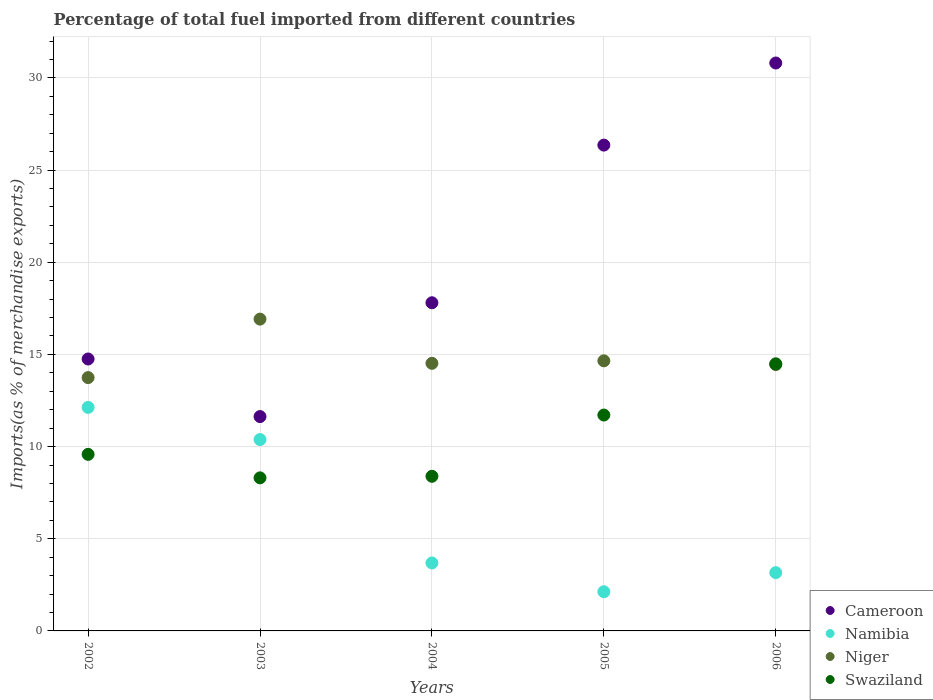How many different coloured dotlines are there?
Your response must be concise. 4. What is the percentage of imports to different countries in Swaziland in 2006?
Offer a terse response. 14.49. Across all years, what is the maximum percentage of imports to different countries in Niger?
Make the answer very short. 16.91. Across all years, what is the minimum percentage of imports to different countries in Swaziland?
Provide a short and direct response. 8.3. What is the total percentage of imports to different countries in Niger in the graph?
Your answer should be very brief. 74.28. What is the difference between the percentage of imports to different countries in Swaziland in 2002 and that in 2006?
Offer a very short reply. -4.91. What is the difference between the percentage of imports to different countries in Namibia in 2006 and the percentage of imports to different countries in Cameroon in 2004?
Make the answer very short. -14.64. What is the average percentage of imports to different countries in Cameroon per year?
Your response must be concise. 20.27. In the year 2004, what is the difference between the percentage of imports to different countries in Niger and percentage of imports to different countries in Cameroon?
Offer a very short reply. -3.29. In how many years, is the percentage of imports to different countries in Namibia greater than 19 %?
Make the answer very short. 0. What is the ratio of the percentage of imports to different countries in Namibia in 2004 to that in 2006?
Provide a short and direct response. 1.17. Is the percentage of imports to different countries in Cameroon in 2002 less than that in 2003?
Your answer should be very brief. No. What is the difference between the highest and the second highest percentage of imports to different countries in Cameroon?
Offer a very short reply. 4.45. What is the difference between the highest and the lowest percentage of imports to different countries in Cameroon?
Give a very brief answer. 19.18. Is the sum of the percentage of imports to different countries in Swaziland in 2005 and 2006 greater than the maximum percentage of imports to different countries in Namibia across all years?
Offer a terse response. Yes. Is it the case that in every year, the sum of the percentage of imports to different countries in Niger and percentage of imports to different countries in Cameroon  is greater than the sum of percentage of imports to different countries in Swaziland and percentage of imports to different countries in Namibia?
Make the answer very short. No. Is it the case that in every year, the sum of the percentage of imports to different countries in Namibia and percentage of imports to different countries in Swaziland  is greater than the percentage of imports to different countries in Niger?
Offer a very short reply. No. Does the percentage of imports to different countries in Niger monotonically increase over the years?
Make the answer very short. No. Is the percentage of imports to different countries in Niger strictly greater than the percentage of imports to different countries in Swaziland over the years?
Offer a very short reply. No. Is the percentage of imports to different countries in Niger strictly less than the percentage of imports to different countries in Swaziland over the years?
Offer a very short reply. No. How many years are there in the graph?
Offer a very short reply. 5. Are the values on the major ticks of Y-axis written in scientific E-notation?
Provide a short and direct response. No. How many legend labels are there?
Make the answer very short. 4. How are the legend labels stacked?
Offer a terse response. Vertical. What is the title of the graph?
Your response must be concise. Percentage of total fuel imported from different countries. What is the label or title of the X-axis?
Your response must be concise. Years. What is the label or title of the Y-axis?
Provide a succinct answer. Imports(as % of merchandise exports). What is the Imports(as % of merchandise exports) in Cameroon in 2002?
Your answer should be compact. 14.75. What is the Imports(as % of merchandise exports) in Namibia in 2002?
Your answer should be very brief. 12.13. What is the Imports(as % of merchandise exports) of Niger in 2002?
Provide a succinct answer. 13.74. What is the Imports(as % of merchandise exports) of Swaziland in 2002?
Provide a short and direct response. 9.58. What is the Imports(as % of merchandise exports) in Cameroon in 2003?
Ensure brevity in your answer.  11.63. What is the Imports(as % of merchandise exports) in Namibia in 2003?
Give a very brief answer. 10.38. What is the Imports(as % of merchandise exports) of Niger in 2003?
Your answer should be compact. 16.91. What is the Imports(as % of merchandise exports) of Swaziland in 2003?
Offer a terse response. 8.3. What is the Imports(as % of merchandise exports) of Cameroon in 2004?
Offer a very short reply. 17.8. What is the Imports(as % of merchandise exports) of Namibia in 2004?
Make the answer very short. 3.69. What is the Imports(as % of merchandise exports) in Niger in 2004?
Make the answer very short. 14.52. What is the Imports(as % of merchandise exports) of Swaziland in 2004?
Your response must be concise. 8.39. What is the Imports(as % of merchandise exports) in Cameroon in 2005?
Offer a terse response. 26.35. What is the Imports(as % of merchandise exports) of Namibia in 2005?
Provide a short and direct response. 2.13. What is the Imports(as % of merchandise exports) of Niger in 2005?
Ensure brevity in your answer.  14.65. What is the Imports(as % of merchandise exports) of Swaziland in 2005?
Keep it short and to the point. 11.71. What is the Imports(as % of merchandise exports) of Cameroon in 2006?
Make the answer very short. 30.81. What is the Imports(as % of merchandise exports) in Namibia in 2006?
Make the answer very short. 3.16. What is the Imports(as % of merchandise exports) in Niger in 2006?
Provide a short and direct response. 14.45. What is the Imports(as % of merchandise exports) in Swaziland in 2006?
Offer a terse response. 14.49. Across all years, what is the maximum Imports(as % of merchandise exports) in Cameroon?
Your answer should be compact. 30.81. Across all years, what is the maximum Imports(as % of merchandise exports) in Namibia?
Provide a short and direct response. 12.13. Across all years, what is the maximum Imports(as % of merchandise exports) of Niger?
Your answer should be compact. 16.91. Across all years, what is the maximum Imports(as % of merchandise exports) in Swaziland?
Make the answer very short. 14.49. Across all years, what is the minimum Imports(as % of merchandise exports) of Cameroon?
Ensure brevity in your answer.  11.63. Across all years, what is the minimum Imports(as % of merchandise exports) in Namibia?
Provide a succinct answer. 2.13. Across all years, what is the minimum Imports(as % of merchandise exports) in Niger?
Provide a succinct answer. 13.74. Across all years, what is the minimum Imports(as % of merchandise exports) in Swaziland?
Offer a terse response. 8.3. What is the total Imports(as % of merchandise exports) in Cameroon in the graph?
Provide a succinct answer. 101.35. What is the total Imports(as % of merchandise exports) in Namibia in the graph?
Give a very brief answer. 31.48. What is the total Imports(as % of merchandise exports) of Niger in the graph?
Keep it short and to the point. 74.28. What is the total Imports(as % of merchandise exports) of Swaziland in the graph?
Offer a terse response. 52.47. What is the difference between the Imports(as % of merchandise exports) in Cameroon in 2002 and that in 2003?
Offer a very short reply. 3.12. What is the difference between the Imports(as % of merchandise exports) of Namibia in 2002 and that in 2003?
Keep it short and to the point. 1.74. What is the difference between the Imports(as % of merchandise exports) in Niger in 2002 and that in 2003?
Offer a very short reply. -3.17. What is the difference between the Imports(as % of merchandise exports) in Swaziland in 2002 and that in 2003?
Make the answer very short. 1.28. What is the difference between the Imports(as % of merchandise exports) of Cameroon in 2002 and that in 2004?
Offer a very short reply. -3.05. What is the difference between the Imports(as % of merchandise exports) of Namibia in 2002 and that in 2004?
Keep it short and to the point. 8.44. What is the difference between the Imports(as % of merchandise exports) of Niger in 2002 and that in 2004?
Provide a succinct answer. -0.78. What is the difference between the Imports(as % of merchandise exports) in Swaziland in 2002 and that in 2004?
Make the answer very short. 1.19. What is the difference between the Imports(as % of merchandise exports) of Cameroon in 2002 and that in 2005?
Provide a succinct answer. -11.6. What is the difference between the Imports(as % of merchandise exports) in Namibia in 2002 and that in 2005?
Make the answer very short. 10. What is the difference between the Imports(as % of merchandise exports) of Niger in 2002 and that in 2005?
Your response must be concise. -0.91. What is the difference between the Imports(as % of merchandise exports) of Swaziland in 2002 and that in 2005?
Your response must be concise. -2.13. What is the difference between the Imports(as % of merchandise exports) of Cameroon in 2002 and that in 2006?
Make the answer very short. -16.06. What is the difference between the Imports(as % of merchandise exports) in Namibia in 2002 and that in 2006?
Provide a short and direct response. 8.96. What is the difference between the Imports(as % of merchandise exports) of Niger in 2002 and that in 2006?
Give a very brief answer. -0.71. What is the difference between the Imports(as % of merchandise exports) in Swaziland in 2002 and that in 2006?
Your answer should be compact. -4.91. What is the difference between the Imports(as % of merchandise exports) in Cameroon in 2003 and that in 2004?
Your answer should be compact. -6.17. What is the difference between the Imports(as % of merchandise exports) in Namibia in 2003 and that in 2004?
Your answer should be compact. 6.69. What is the difference between the Imports(as % of merchandise exports) in Niger in 2003 and that in 2004?
Your answer should be compact. 2.4. What is the difference between the Imports(as % of merchandise exports) of Swaziland in 2003 and that in 2004?
Provide a short and direct response. -0.09. What is the difference between the Imports(as % of merchandise exports) of Cameroon in 2003 and that in 2005?
Your answer should be compact. -14.73. What is the difference between the Imports(as % of merchandise exports) in Namibia in 2003 and that in 2005?
Your answer should be compact. 8.26. What is the difference between the Imports(as % of merchandise exports) in Niger in 2003 and that in 2005?
Offer a very short reply. 2.26. What is the difference between the Imports(as % of merchandise exports) in Swaziland in 2003 and that in 2005?
Make the answer very short. -3.41. What is the difference between the Imports(as % of merchandise exports) in Cameroon in 2003 and that in 2006?
Ensure brevity in your answer.  -19.18. What is the difference between the Imports(as % of merchandise exports) in Namibia in 2003 and that in 2006?
Your answer should be very brief. 7.22. What is the difference between the Imports(as % of merchandise exports) in Niger in 2003 and that in 2006?
Give a very brief answer. 2.47. What is the difference between the Imports(as % of merchandise exports) in Swaziland in 2003 and that in 2006?
Make the answer very short. -6.19. What is the difference between the Imports(as % of merchandise exports) in Cameroon in 2004 and that in 2005?
Offer a terse response. -8.55. What is the difference between the Imports(as % of merchandise exports) in Namibia in 2004 and that in 2005?
Give a very brief answer. 1.56. What is the difference between the Imports(as % of merchandise exports) of Niger in 2004 and that in 2005?
Give a very brief answer. -0.14. What is the difference between the Imports(as % of merchandise exports) in Swaziland in 2004 and that in 2005?
Make the answer very short. -3.32. What is the difference between the Imports(as % of merchandise exports) in Cameroon in 2004 and that in 2006?
Ensure brevity in your answer.  -13.01. What is the difference between the Imports(as % of merchandise exports) of Namibia in 2004 and that in 2006?
Provide a short and direct response. 0.53. What is the difference between the Imports(as % of merchandise exports) of Niger in 2004 and that in 2006?
Your answer should be very brief. 0.07. What is the difference between the Imports(as % of merchandise exports) of Swaziland in 2004 and that in 2006?
Offer a terse response. -6.1. What is the difference between the Imports(as % of merchandise exports) in Cameroon in 2005 and that in 2006?
Offer a terse response. -4.45. What is the difference between the Imports(as % of merchandise exports) in Namibia in 2005 and that in 2006?
Your answer should be compact. -1.04. What is the difference between the Imports(as % of merchandise exports) of Niger in 2005 and that in 2006?
Offer a terse response. 0.2. What is the difference between the Imports(as % of merchandise exports) in Swaziland in 2005 and that in 2006?
Give a very brief answer. -2.78. What is the difference between the Imports(as % of merchandise exports) in Cameroon in 2002 and the Imports(as % of merchandise exports) in Namibia in 2003?
Provide a short and direct response. 4.37. What is the difference between the Imports(as % of merchandise exports) in Cameroon in 2002 and the Imports(as % of merchandise exports) in Niger in 2003?
Provide a succinct answer. -2.16. What is the difference between the Imports(as % of merchandise exports) of Cameroon in 2002 and the Imports(as % of merchandise exports) of Swaziland in 2003?
Provide a short and direct response. 6.45. What is the difference between the Imports(as % of merchandise exports) of Namibia in 2002 and the Imports(as % of merchandise exports) of Niger in 2003?
Provide a succinct answer. -4.79. What is the difference between the Imports(as % of merchandise exports) in Namibia in 2002 and the Imports(as % of merchandise exports) in Swaziland in 2003?
Ensure brevity in your answer.  3.82. What is the difference between the Imports(as % of merchandise exports) of Niger in 2002 and the Imports(as % of merchandise exports) of Swaziland in 2003?
Make the answer very short. 5.44. What is the difference between the Imports(as % of merchandise exports) in Cameroon in 2002 and the Imports(as % of merchandise exports) in Namibia in 2004?
Your answer should be compact. 11.06. What is the difference between the Imports(as % of merchandise exports) in Cameroon in 2002 and the Imports(as % of merchandise exports) in Niger in 2004?
Ensure brevity in your answer.  0.23. What is the difference between the Imports(as % of merchandise exports) in Cameroon in 2002 and the Imports(as % of merchandise exports) in Swaziland in 2004?
Provide a succinct answer. 6.36. What is the difference between the Imports(as % of merchandise exports) in Namibia in 2002 and the Imports(as % of merchandise exports) in Niger in 2004?
Your answer should be very brief. -2.39. What is the difference between the Imports(as % of merchandise exports) in Namibia in 2002 and the Imports(as % of merchandise exports) in Swaziland in 2004?
Provide a succinct answer. 3.74. What is the difference between the Imports(as % of merchandise exports) of Niger in 2002 and the Imports(as % of merchandise exports) of Swaziland in 2004?
Your answer should be very brief. 5.35. What is the difference between the Imports(as % of merchandise exports) in Cameroon in 2002 and the Imports(as % of merchandise exports) in Namibia in 2005?
Provide a short and direct response. 12.63. What is the difference between the Imports(as % of merchandise exports) in Cameroon in 2002 and the Imports(as % of merchandise exports) in Niger in 2005?
Make the answer very short. 0.1. What is the difference between the Imports(as % of merchandise exports) of Cameroon in 2002 and the Imports(as % of merchandise exports) of Swaziland in 2005?
Make the answer very short. 3.04. What is the difference between the Imports(as % of merchandise exports) of Namibia in 2002 and the Imports(as % of merchandise exports) of Niger in 2005?
Offer a very short reply. -2.53. What is the difference between the Imports(as % of merchandise exports) of Namibia in 2002 and the Imports(as % of merchandise exports) of Swaziland in 2005?
Provide a short and direct response. 0.41. What is the difference between the Imports(as % of merchandise exports) of Niger in 2002 and the Imports(as % of merchandise exports) of Swaziland in 2005?
Offer a terse response. 2.03. What is the difference between the Imports(as % of merchandise exports) of Cameroon in 2002 and the Imports(as % of merchandise exports) of Namibia in 2006?
Provide a succinct answer. 11.59. What is the difference between the Imports(as % of merchandise exports) in Cameroon in 2002 and the Imports(as % of merchandise exports) in Niger in 2006?
Provide a short and direct response. 0.3. What is the difference between the Imports(as % of merchandise exports) of Cameroon in 2002 and the Imports(as % of merchandise exports) of Swaziland in 2006?
Ensure brevity in your answer.  0.26. What is the difference between the Imports(as % of merchandise exports) in Namibia in 2002 and the Imports(as % of merchandise exports) in Niger in 2006?
Give a very brief answer. -2.32. What is the difference between the Imports(as % of merchandise exports) in Namibia in 2002 and the Imports(as % of merchandise exports) in Swaziland in 2006?
Make the answer very short. -2.36. What is the difference between the Imports(as % of merchandise exports) of Niger in 2002 and the Imports(as % of merchandise exports) of Swaziland in 2006?
Provide a succinct answer. -0.75. What is the difference between the Imports(as % of merchandise exports) of Cameroon in 2003 and the Imports(as % of merchandise exports) of Namibia in 2004?
Make the answer very short. 7.94. What is the difference between the Imports(as % of merchandise exports) of Cameroon in 2003 and the Imports(as % of merchandise exports) of Niger in 2004?
Provide a succinct answer. -2.89. What is the difference between the Imports(as % of merchandise exports) of Cameroon in 2003 and the Imports(as % of merchandise exports) of Swaziland in 2004?
Provide a succinct answer. 3.24. What is the difference between the Imports(as % of merchandise exports) in Namibia in 2003 and the Imports(as % of merchandise exports) in Niger in 2004?
Ensure brevity in your answer.  -4.14. What is the difference between the Imports(as % of merchandise exports) in Namibia in 2003 and the Imports(as % of merchandise exports) in Swaziland in 2004?
Your response must be concise. 1.99. What is the difference between the Imports(as % of merchandise exports) in Niger in 2003 and the Imports(as % of merchandise exports) in Swaziland in 2004?
Give a very brief answer. 8.53. What is the difference between the Imports(as % of merchandise exports) of Cameroon in 2003 and the Imports(as % of merchandise exports) of Namibia in 2005?
Make the answer very short. 9.5. What is the difference between the Imports(as % of merchandise exports) in Cameroon in 2003 and the Imports(as % of merchandise exports) in Niger in 2005?
Your response must be concise. -3.02. What is the difference between the Imports(as % of merchandise exports) of Cameroon in 2003 and the Imports(as % of merchandise exports) of Swaziland in 2005?
Your answer should be compact. -0.08. What is the difference between the Imports(as % of merchandise exports) of Namibia in 2003 and the Imports(as % of merchandise exports) of Niger in 2005?
Provide a short and direct response. -4.27. What is the difference between the Imports(as % of merchandise exports) in Namibia in 2003 and the Imports(as % of merchandise exports) in Swaziland in 2005?
Give a very brief answer. -1.33. What is the difference between the Imports(as % of merchandise exports) of Niger in 2003 and the Imports(as % of merchandise exports) of Swaziland in 2005?
Your response must be concise. 5.2. What is the difference between the Imports(as % of merchandise exports) in Cameroon in 2003 and the Imports(as % of merchandise exports) in Namibia in 2006?
Your response must be concise. 8.47. What is the difference between the Imports(as % of merchandise exports) of Cameroon in 2003 and the Imports(as % of merchandise exports) of Niger in 2006?
Ensure brevity in your answer.  -2.82. What is the difference between the Imports(as % of merchandise exports) in Cameroon in 2003 and the Imports(as % of merchandise exports) in Swaziland in 2006?
Your answer should be compact. -2.86. What is the difference between the Imports(as % of merchandise exports) in Namibia in 2003 and the Imports(as % of merchandise exports) in Niger in 2006?
Your answer should be compact. -4.07. What is the difference between the Imports(as % of merchandise exports) of Namibia in 2003 and the Imports(as % of merchandise exports) of Swaziland in 2006?
Make the answer very short. -4.11. What is the difference between the Imports(as % of merchandise exports) of Niger in 2003 and the Imports(as % of merchandise exports) of Swaziland in 2006?
Offer a very short reply. 2.42. What is the difference between the Imports(as % of merchandise exports) in Cameroon in 2004 and the Imports(as % of merchandise exports) in Namibia in 2005?
Your response must be concise. 15.68. What is the difference between the Imports(as % of merchandise exports) in Cameroon in 2004 and the Imports(as % of merchandise exports) in Niger in 2005?
Offer a terse response. 3.15. What is the difference between the Imports(as % of merchandise exports) in Cameroon in 2004 and the Imports(as % of merchandise exports) in Swaziland in 2005?
Offer a very short reply. 6.09. What is the difference between the Imports(as % of merchandise exports) in Namibia in 2004 and the Imports(as % of merchandise exports) in Niger in 2005?
Give a very brief answer. -10.97. What is the difference between the Imports(as % of merchandise exports) in Namibia in 2004 and the Imports(as % of merchandise exports) in Swaziland in 2005?
Offer a very short reply. -8.02. What is the difference between the Imports(as % of merchandise exports) of Niger in 2004 and the Imports(as % of merchandise exports) of Swaziland in 2005?
Make the answer very short. 2.81. What is the difference between the Imports(as % of merchandise exports) of Cameroon in 2004 and the Imports(as % of merchandise exports) of Namibia in 2006?
Provide a succinct answer. 14.64. What is the difference between the Imports(as % of merchandise exports) of Cameroon in 2004 and the Imports(as % of merchandise exports) of Niger in 2006?
Offer a very short reply. 3.35. What is the difference between the Imports(as % of merchandise exports) in Cameroon in 2004 and the Imports(as % of merchandise exports) in Swaziland in 2006?
Your answer should be compact. 3.31. What is the difference between the Imports(as % of merchandise exports) of Namibia in 2004 and the Imports(as % of merchandise exports) of Niger in 2006?
Keep it short and to the point. -10.76. What is the difference between the Imports(as % of merchandise exports) in Namibia in 2004 and the Imports(as % of merchandise exports) in Swaziland in 2006?
Keep it short and to the point. -10.8. What is the difference between the Imports(as % of merchandise exports) in Niger in 2004 and the Imports(as % of merchandise exports) in Swaziland in 2006?
Your answer should be very brief. 0.03. What is the difference between the Imports(as % of merchandise exports) in Cameroon in 2005 and the Imports(as % of merchandise exports) in Namibia in 2006?
Your response must be concise. 23.19. What is the difference between the Imports(as % of merchandise exports) of Cameroon in 2005 and the Imports(as % of merchandise exports) of Niger in 2006?
Your answer should be compact. 11.91. What is the difference between the Imports(as % of merchandise exports) in Cameroon in 2005 and the Imports(as % of merchandise exports) in Swaziland in 2006?
Give a very brief answer. 11.87. What is the difference between the Imports(as % of merchandise exports) in Namibia in 2005 and the Imports(as % of merchandise exports) in Niger in 2006?
Ensure brevity in your answer.  -12.32. What is the difference between the Imports(as % of merchandise exports) of Namibia in 2005 and the Imports(as % of merchandise exports) of Swaziland in 2006?
Provide a short and direct response. -12.36. What is the difference between the Imports(as % of merchandise exports) in Niger in 2005 and the Imports(as % of merchandise exports) in Swaziland in 2006?
Your answer should be very brief. 0.16. What is the average Imports(as % of merchandise exports) in Cameroon per year?
Make the answer very short. 20.27. What is the average Imports(as % of merchandise exports) of Namibia per year?
Ensure brevity in your answer.  6.3. What is the average Imports(as % of merchandise exports) in Niger per year?
Offer a very short reply. 14.86. What is the average Imports(as % of merchandise exports) of Swaziland per year?
Provide a short and direct response. 10.49. In the year 2002, what is the difference between the Imports(as % of merchandise exports) of Cameroon and Imports(as % of merchandise exports) of Namibia?
Ensure brevity in your answer.  2.63. In the year 2002, what is the difference between the Imports(as % of merchandise exports) of Cameroon and Imports(as % of merchandise exports) of Niger?
Make the answer very short. 1.01. In the year 2002, what is the difference between the Imports(as % of merchandise exports) in Cameroon and Imports(as % of merchandise exports) in Swaziland?
Offer a terse response. 5.17. In the year 2002, what is the difference between the Imports(as % of merchandise exports) of Namibia and Imports(as % of merchandise exports) of Niger?
Make the answer very short. -1.62. In the year 2002, what is the difference between the Imports(as % of merchandise exports) of Namibia and Imports(as % of merchandise exports) of Swaziland?
Your answer should be very brief. 2.55. In the year 2002, what is the difference between the Imports(as % of merchandise exports) in Niger and Imports(as % of merchandise exports) in Swaziland?
Your answer should be compact. 4.16. In the year 2003, what is the difference between the Imports(as % of merchandise exports) in Cameroon and Imports(as % of merchandise exports) in Namibia?
Your answer should be very brief. 1.25. In the year 2003, what is the difference between the Imports(as % of merchandise exports) of Cameroon and Imports(as % of merchandise exports) of Niger?
Make the answer very short. -5.29. In the year 2003, what is the difference between the Imports(as % of merchandise exports) in Cameroon and Imports(as % of merchandise exports) in Swaziland?
Your response must be concise. 3.32. In the year 2003, what is the difference between the Imports(as % of merchandise exports) of Namibia and Imports(as % of merchandise exports) of Niger?
Your answer should be very brief. -6.53. In the year 2003, what is the difference between the Imports(as % of merchandise exports) of Namibia and Imports(as % of merchandise exports) of Swaziland?
Your answer should be very brief. 2.08. In the year 2003, what is the difference between the Imports(as % of merchandise exports) in Niger and Imports(as % of merchandise exports) in Swaziland?
Provide a short and direct response. 8.61. In the year 2004, what is the difference between the Imports(as % of merchandise exports) of Cameroon and Imports(as % of merchandise exports) of Namibia?
Your response must be concise. 14.12. In the year 2004, what is the difference between the Imports(as % of merchandise exports) of Cameroon and Imports(as % of merchandise exports) of Niger?
Ensure brevity in your answer.  3.29. In the year 2004, what is the difference between the Imports(as % of merchandise exports) of Cameroon and Imports(as % of merchandise exports) of Swaziland?
Provide a succinct answer. 9.41. In the year 2004, what is the difference between the Imports(as % of merchandise exports) of Namibia and Imports(as % of merchandise exports) of Niger?
Provide a short and direct response. -10.83. In the year 2004, what is the difference between the Imports(as % of merchandise exports) in Namibia and Imports(as % of merchandise exports) in Swaziland?
Offer a very short reply. -4.7. In the year 2004, what is the difference between the Imports(as % of merchandise exports) of Niger and Imports(as % of merchandise exports) of Swaziland?
Ensure brevity in your answer.  6.13. In the year 2005, what is the difference between the Imports(as % of merchandise exports) of Cameroon and Imports(as % of merchandise exports) of Namibia?
Ensure brevity in your answer.  24.23. In the year 2005, what is the difference between the Imports(as % of merchandise exports) of Cameroon and Imports(as % of merchandise exports) of Niger?
Your answer should be compact. 11.7. In the year 2005, what is the difference between the Imports(as % of merchandise exports) in Cameroon and Imports(as % of merchandise exports) in Swaziland?
Offer a very short reply. 14.64. In the year 2005, what is the difference between the Imports(as % of merchandise exports) in Namibia and Imports(as % of merchandise exports) in Niger?
Keep it short and to the point. -12.53. In the year 2005, what is the difference between the Imports(as % of merchandise exports) of Namibia and Imports(as % of merchandise exports) of Swaziland?
Offer a very short reply. -9.59. In the year 2005, what is the difference between the Imports(as % of merchandise exports) of Niger and Imports(as % of merchandise exports) of Swaziland?
Provide a succinct answer. 2.94. In the year 2006, what is the difference between the Imports(as % of merchandise exports) of Cameroon and Imports(as % of merchandise exports) of Namibia?
Your answer should be very brief. 27.65. In the year 2006, what is the difference between the Imports(as % of merchandise exports) of Cameroon and Imports(as % of merchandise exports) of Niger?
Keep it short and to the point. 16.36. In the year 2006, what is the difference between the Imports(as % of merchandise exports) of Cameroon and Imports(as % of merchandise exports) of Swaziland?
Make the answer very short. 16.32. In the year 2006, what is the difference between the Imports(as % of merchandise exports) of Namibia and Imports(as % of merchandise exports) of Niger?
Provide a succinct answer. -11.29. In the year 2006, what is the difference between the Imports(as % of merchandise exports) in Namibia and Imports(as % of merchandise exports) in Swaziland?
Give a very brief answer. -11.33. In the year 2006, what is the difference between the Imports(as % of merchandise exports) in Niger and Imports(as % of merchandise exports) in Swaziland?
Offer a very short reply. -0.04. What is the ratio of the Imports(as % of merchandise exports) in Cameroon in 2002 to that in 2003?
Give a very brief answer. 1.27. What is the ratio of the Imports(as % of merchandise exports) in Namibia in 2002 to that in 2003?
Your response must be concise. 1.17. What is the ratio of the Imports(as % of merchandise exports) in Niger in 2002 to that in 2003?
Make the answer very short. 0.81. What is the ratio of the Imports(as % of merchandise exports) in Swaziland in 2002 to that in 2003?
Offer a terse response. 1.15. What is the ratio of the Imports(as % of merchandise exports) of Cameroon in 2002 to that in 2004?
Make the answer very short. 0.83. What is the ratio of the Imports(as % of merchandise exports) of Namibia in 2002 to that in 2004?
Ensure brevity in your answer.  3.29. What is the ratio of the Imports(as % of merchandise exports) in Niger in 2002 to that in 2004?
Offer a very short reply. 0.95. What is the ratio of the Imports(as % of merchandise exports) in Swaziland in 2002 to that in 2004?
Offer a very short reply. 1.14. What is the ratio of the Imports(as % of merchandise exports) in Cameroon in 2002 to that in 2005?
Your answer should be compact. 0.56. What is the ratio of the Imports(as % of merchandise exports) in Namibia in 2002 to that in 2005?
Provide a short and direct response. 5.71. What is the ratio of the Imports(as % of merchandise exports) in Niger in 2002 to that in 2005?
Offer a terse response. 0.94. What is the ratio of the Imports(as % of merchandise exports) of Swaziland in 2002 to that in 2005?
Ensure brevity in your answer.  0.82. What is the ratio of the Imports(as % of merchandise exports) of Cameroon in 2002 to that in 2006?
Ensure brevity in your answer.  0.48. What is the ratio of the Imports(as % of merchandise exports) of Namibia in 2002 to that in 2006?
Provide a short and direct response. 3.84. What is the ratio of the Imports(as % of merchandise exports) of Niger in 2002 to that in 2006?
Provide a succinct answer. 0.95. What is the ratio of the Imports(as % of merchandise exports) in Swaziland in 2002 to that in 2006?
Offer a terse response. 0.66. What is the ratio of the Imports(as % of merchandise exports) in Cameroon in 2003 to that in 2004?
Keep it short and to the point. 0.65. What is the ratio of the Imports(as % of merchandise exports) in Namibia in 2003 to that in 2004?
Make the answer very short. 2.82. What is the ratio of the Imports(as % of merchandise exports) in Niger in 2003 to that in 2004?
Your answer should be compact. 1.17. What is the ratio of the Imports(as % of merchandise exports) of Swaziland in 2003 to that in 2004?
Make the answer very short. 0.99. What is the ratio of the Imports(as % of merchandise exports) of Cameroon in 2003 to that in 2005?
Provide a succinct answer. 0.44. What is the ratio of the Imports(as % of merchandise exports) of Namibia in 2003 to that in 2005?
Provide a short and direct response. 4.88. What is the ratio of the Imports(as % of merchandise exports) of Niger in 2003 to that in 2005?
Keep it short and to the point. 1.15. What is the ratio of the Imports(as % of merchandise exports) of Swaziland in 2003 to that in 2005?
Provide a succinct answer. 0.71. What is the ratio of the Imports(as % of merchandise exports) in Cameroon in 2003 to that in 2006?
Make the answer very short. 0.38. What is the ratio of the Imports(as % of merchandise exports) in Namibia in 2003 to that in 2006?
Your answer should be very brief. 3.28. What is the ratio of the Imports(as % of merchandise exports) of Niger in 2003 to that in 2006?
Ensure brevity in your answer.  1.17. What is the ratio of the Imports(as % of merchandise exports) in Swaziland in 2003 to that in 2006?
Ensure brevity in your answer.  0.57. What is the ratio of the Imports(as % of merchandise exports) of Cameroon in 2004 to that in 2005?
Keep it short and to the point. 0.68. What is the ratio of the Imports(as % of merchandise exports) in Namibia in 2004 to that in 2005?
Make the answer very short. 1.73. What is the ratio of the Imports(as % of merchandise exports) of Niger in 2004 to that in 2005?
Keep it short and to the point. 0.99. What is the ratio of the Imports(as % of merchandise exports) of Swaziland in 2004 to that in 2005?
Offer a very short reply. 0.72. What is the ratio of the Imports(as % of merchandise exports) of Cameroon in 2004 to that in 2006?
Ensure brevity in your answer.  0.58. What is the ratio of the Imports(as % of merchandise exports) of Namibia in 2004 to that in 2006?
Provide a short and direct response. 1.17. What is the ratio of the Imports(as % of merchandise exports) of Swaziland in 2004 to that in 2006?
Your response must be concise. 0.58. What is the ratio of the Imports(as % of merchandise exports) in Cameroon in 2005 to that in 2006?
Provide a short and direct response. 0.86. What is the ratio of the Imports(as % of merchandise exports) in Namibia in 2005 to that in 2006?
Offer a very short reply. 0.67. What is the ratio of the Imports(as % of merchandise exports) of Niger in 2005 to that in 2006?
Provide a succinct answer. 1.01. What is the ratio of the Imports(as % of merchandise exports) in Swaziland in 2005 to that in 2006?
Make the answer very short. 0.81. What is the difference between the highest and the second highest Imports(as % of merchandise exports) in Cameroon?
Make the answer very short. 4.45. What is the difference between the highest and the second highest Imports(as % of merchandise exports) of Namibia?
Provide a succinct answer. 1.74. What is the difference between the highest and the second highest Imports(as % of merchandise exports) of Niger?
Give a very brief answer. 2.26. What is the difference between the highest and the second highest Imports(as % of merchandise exports) of Swaziland?
Make the answer very short. 2.78. What is the difference between the highest and the lowest Imports(as % of merchandise exports) in Cameroon?
Keep it short and to the point. 19.18. What is the difference between the highest and the lowest Imports(as % of merchandise exports) of Namibia?
Give a very brief answer. 10. What is the difference between the highest and the lowest Imports(as % of merchandise exports) in Niger?
Ensure brevity in your answer.  3.17. What is the difference between the highest and the lowest Imports(as % of merchandise exports) in Swaziland?
Make the answer very short. 6.19. 